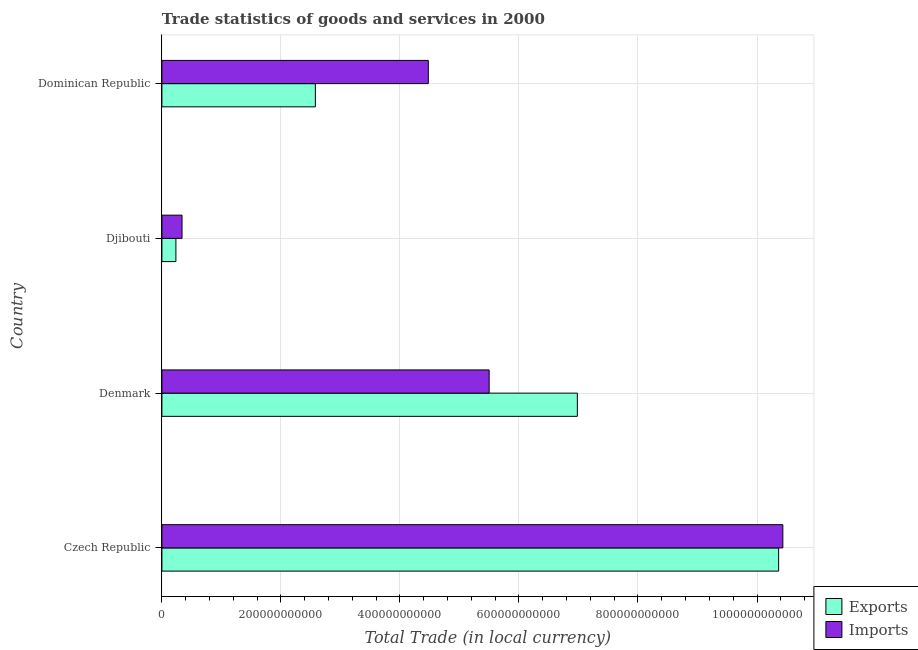How many groups of bars are there?
Ensure brevity in your answer.  4. Are the number of bars on each tick of the Y-axis equal?
Your answer should be compact. Yes. How many bars are there on the 3rd tick from the top?
Provide a succinct answer. 2. What is the export of goods and services in Czech Republic?
Offer a terse response. 1.04e+12. Across all countries, what is the maximum imports of goods and services?
Provide a short and direct response. 1.04e+12. Across all countries, what is the minimum export of goods and services?
Your response must be concise. 2.35e+1. In which country was the imports of goods and services maximum?
Provide a short and direct response. Czech Republic. In which country was the export of goods and services minimum?
Provide a succinct answer. Djibouti. What is the total imports of goods and services in the graph?
Keep it short and to the point. 2.07e+12. What is the difference between the imports of goods and services in Czech Republic and that in Djibouti?
Provide a short and direct response. 1.01e+12. What is the difference between the imports of goods and services in Czech Republic and the export of goods and services in Denmark?
Your answer should be compact. 3.45e+11. What is the average imports of goods and services per country?
Your answer should be compact. 5.19e+11. What is the difference between the export of goods and services and imports of goods and services in Denmark?
Provide a succinct answer. 1.48e+11. In how many countries, is the imports of goods and services greater than 760000000000 LCU?
Offer a terse response. 1. What is the ratio of the export of goods and services in Djibouti to that in Dominican Republic?
Provide a succinct answer. 0.09. Is the difference between the export of goods and services in Denmark and Djibouti greater than the difference between the imports of goods and services in Denmark and Djibouti?
Keep it short and to the point. Yes. What is the difference between the highest and the second highest export of goods and services?
Make the answer very short. 3.38e+11. What is the difference between the highest and the lowest imports of goods and services?
Offer a terse response. 1.01e+12. Is the sum of the imports of goods and services in Czech Republic and Dominican Republic greater than the maximum export of goods and services across all countries?
Your answer should be compact. Yes. What does the 1st bar from the top in Djibouti represents?
Provide a short and direct response. Imports. What does the 1st bar from the bottom in Djibouti represents?
Ensure brevity in your answer.  Exports. Are all the bars in the graph horizontal?
Offer a terse response. Yes. What is the difference between two consecutive major ticks on the X-axis?
Give a very brief answer. 2.00e+11. Are the values on the major ticks of X-axis written in scientific E-notation?
Make the answer very short. No. Does the graph contain grids?
Ensure brevity in your answer.  Yes. Where does the legend appear in the graph?
Provide a short and direct response. Bottom right. How many legend labels are there?
Ensure brevity in your answer.  2. How are the legend labels stacked?
Offer a terse response. Vertical. What is the title of the graph?
Offer a very short reply. Trade statistics of goods and services in 2000. What is the label or title of the X-axis?
Provide a succinct answer. Total Trade (in local currency). What is the Total Trade (in local currency) in Exports in Czech Republic?
Your answer should be very brief. 1.04e+12. What is the Total Trade (in local currency) in Imports in Czech Republic?
Offer a very short reply. 1.04e+12. What is the Total Trade (in local currency) of Exports in Denmark?
Provide a succinct answer. 6.98e+11. What is the Total Trade (in local currency) in Imports in Denmark?
Your answer should be very brief. 5.50e+11. What is the Total Trade (in local currency) of Exports in Djibouti?
Provide a short and direct response. 2.35e+1. What is the Total Trade (in local currency) of Imports in Djibouti?
Your answer should be compact. 3.38e+1. What is the Total Trade (in local currency) of Exports in Dominican Republic?
Your answer should be compact. 2.58e+11. What is the Total Trade (in local currency) in Imports in Dominican Republic?
Provide a short and direct response. 4.48e+11. Across all countries, what is the maximum Total Trade (in local currency) in Exports?
Make the answer very short. 1.04e+12. Across all countries, what is the maximum Total Trade (in local currency) of Imports?
Provide a short and direct response. 1.04e+12. Across all countries, what is the minimum Total Trade (in local currency) in Exports?
Provide a short and direct response. 2.35e+1. Across all countries, what is the minimum Total Trade (in local currency) in Imports?
Your answer should be compact. 3.38e+1. What is the total Total Trade (in local currency) of Exports in the graph?
Keep it short and to the point. 2.02e+12. What is the total Total Trade (in local currency) of Imports in the graph?
Offer a very short reply. 2.07e+12. What is the difference between the Total Trade (in local currency) of Exports in Czech Republic and that in Denmark?
Offer a terse response. 3.38e+11. What is the difference between the Total Trade (in local currency) of Imports in Czech Republic and that in Denmark?
Keep it short and to the point. 4.93e+11. What is the difference between the Total Trade (in local currency) of Exports in Czech Republic and that in Djibouti?
Your answer should be very brief. 1.01e+12. What is the difference between the Total Trade (in local currency) of Imports in Czech Republic and that in Djibouti?
Offer a very short reply. 1.01e+12. What is the difference between the Total Trade (in local currency) in Exports in Czech Republic and that in Dominican Republic?
Your answer should be compact. 7.78e+11. What is the difference between the Total Trade (in local currency) of Imports in Czech Republic and that in Dominican Republic?
Keep it short and to the point. 5.96e+11. What is the difference between the Total Trade (in local currency) of Exports in Denmark and that in Djibouti?
Your answer should be compact. 6.75e+11. What is the difference between the Total Trade (in local currency) in Imports in Denmark and that in Djibouti?
Offer a very short reply. 5.16e+11. What is the difference between the Total Trade (in local currency) of Exports in Denmark and that in Dominican Republic?
Your answer should be very brief. 4.40e+11. What is the difference between the Total Trade (in local currency) of Imports in Denmark and that in Dominican Republic?
Offer a very short reply. 1.02e+11. What is the difference between the Total Trade (in local currency) of Exports in Djibouti and that in Dominican Republic?
Your answer should be compact. -2.34e+11. What is the difference between the Total Trade (in local currency) in Imports in Djibouti and that in Dominican Republic?
Offer a very short reply. -4.14e+11. What is the difference between the Total Trade (in local currency) in Exports in Czech Republic and the Total Trade (in local currency) in Imports in Denmark?
Your answer should be very brief. 4.86e+11. What is the difference between the Total Trade (in local currency) of Exports in Czech Republic and the Total Trade (in local currency) of Imports in Djibouti?
Provide a short and direct response. 1.00e+12. What is the difference between the Total Trade (in local currency) in Exports in Czech Republic and the Total Trade (in local currency) in Imports in Dominican Republic?
Your response must be concise. 5.89e+11. What is the difference between the Total Trade (in local currency) in Exports in Denmark and the Total Trade (in local currency) in Imports in Djibouti?
Provide a succinct answer. 6.64e+11. What is the difference between the Total Trade (in local currency) of Exports in Denmark and the Total Trade (in local currency) of Imports in Dominican Republic?
Offer a very short reply. 2.50e+11. What is the difference between the Total Trade (in local currency) of Exports in Djibouti and the Total Trade (in local currency) of Imports in Dominican Republic?
Ensure brevity in your answer.  -4.24e+11. What is the average Total Trade (in local currency) in Exports per country?
Your answer should be compact. 5.04e+11. What is the average Total Trade (in local currency) of Imports per country?
Your answer should be compact. 5.19e+11. What is the difference between the Total Trade (in local currency) in Exports and Total Trade (in local currency) in Imports in Czech Republic?
Keep it short and to the point. -7.09e+09. What is the difference between the Total Trade (in local currency) of Exports and Total Trade (in local currency) of Imports in Denmark?
Provide a short and direct response. 1.48e+11. What is the difference between the Total Trade (in local currency) in Exports and Total Trade (in local currency) in Imports in Djibouti?
Provide a short and direct response. -1.03e+1. What is the difference between the Total Trade (in local currency) in Exports and Total Trade (in local currency) in Imports in Dominican Republic?
Your answer should be very brief. -1.90e+11. What is the ratio of the Total Trade (in local currency) of Exports in Czech Republic to that in Denmark?
Offer a terse response. 1.48. What is the ratio of the Total Trade (in local currency) in Imports in Czech Republic to that in Denmark?
Keep it short and to the point. 1.9. What is the ratio of the Total Trade (in local currency) in Exports in Czech Republic to that in Djibouti?
Provide a succinct answer. 44.04. What is the ratio of the Total Trade (in local currency) in Imports in Czech Republic to that in Djibouti?
Give a very brief answer. 30.85. What is the ratio of the Total Trade (in local currency) in Exports in Czech Republic to that in Dominican Republic?
Your response must be concise. 4.02. What is the ratio of the Total Trade (in local currency) in Imports in Czech Republic to that in Dominican Republic?
Make the answer very short. 2.33. What is the ratio of the Total Trade (in local currency) in Exports in Denmark to that in Djibouti?
Offer a terse response. 29.67. What is the ratio of the Total Trade (in local currency) in Imports in Denmark to that in Djibouti?
Offer a very short reply. 16.26. What is the ratio of the Total Trade (in local currency) in Exports in Denmark to that in Dominican Republic?
Keep it short and to the point. 2.71. What is the ratio of the Total Trade (in local currency) of Imports in Denmark to that in Dominican Republic?
Your answer should be very brief. 1.23. What is the ratio of the Total Trade (in local currency) of Exports in Djibouti to that in Dominican Republic?
Keep it short and to the point. 0.09. What is the ratio of the Total Trade (in local currency) of Imports in Djibouti to that in Dominican Republic?
Your response must be concise. 0.08. What is the difference between the highest and the second highest Total Trade (in local currency) in Exports?
Provide a succinct answer. 3.38e+11. What is the difference between the highest and the second highest Total Trade (in local currency) in Imports?
Make the answer very short. 4.93e+11. What is the difference between the highest and the lowest Total Trade (in local currency) of Exports?
Provide a succinct answer. 1.01e+12. What is the difference between the highest and the lowest Total Trade (in local currency) in Imports?
Offer a terse response. 1.01e+12. 